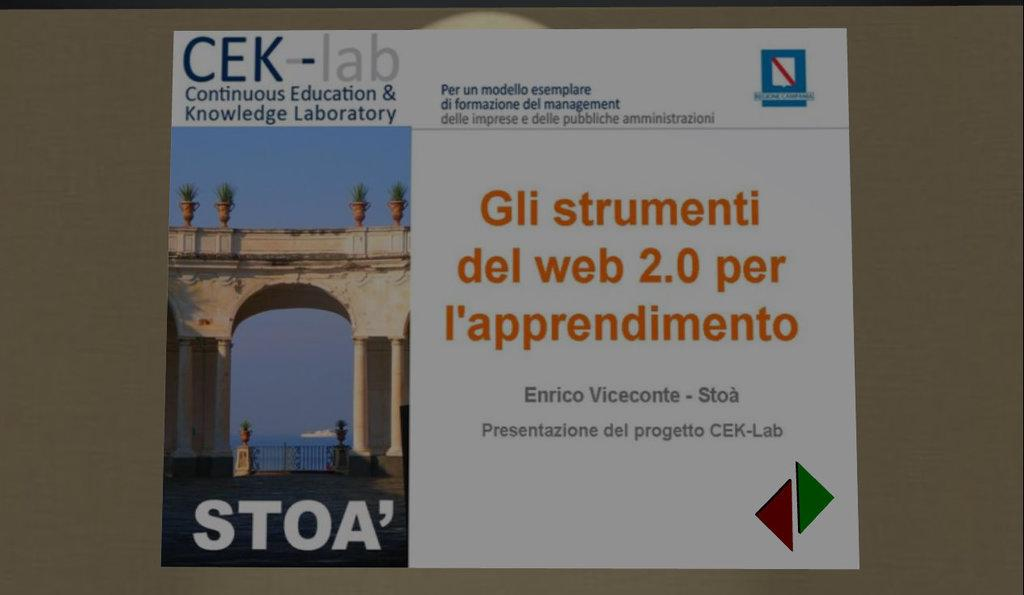<image>
Write a terse but informative summary of the picture. a postcard for STOA on a brownish table 